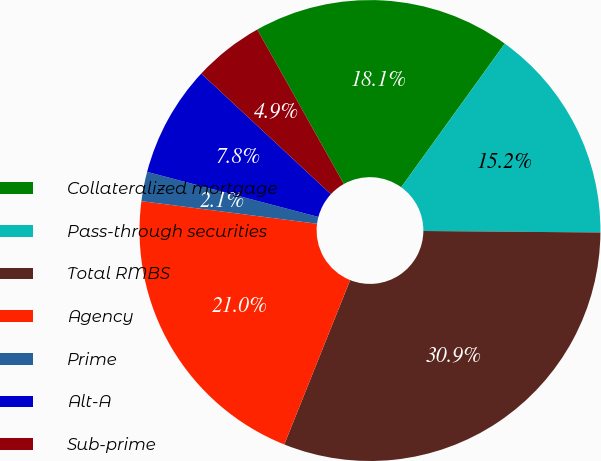Convert chart to OTSL. <chart><loc_0><loc_0><loc_500><loc_500><pie_chart><fcel>Collateralized mortgage<fcel>Pass-through securities<fcel>Total RMBS<fcel>Agency<fcel>Prime<fcel>Alt-A<fcel>Sub-prime<nl><fcel>18.08%<fcel>15.19%<fcel>30.93%<fcel>20.97%<fcel>2.06%<fcel>7.83%<fcel>4.94%<nl></chart> 